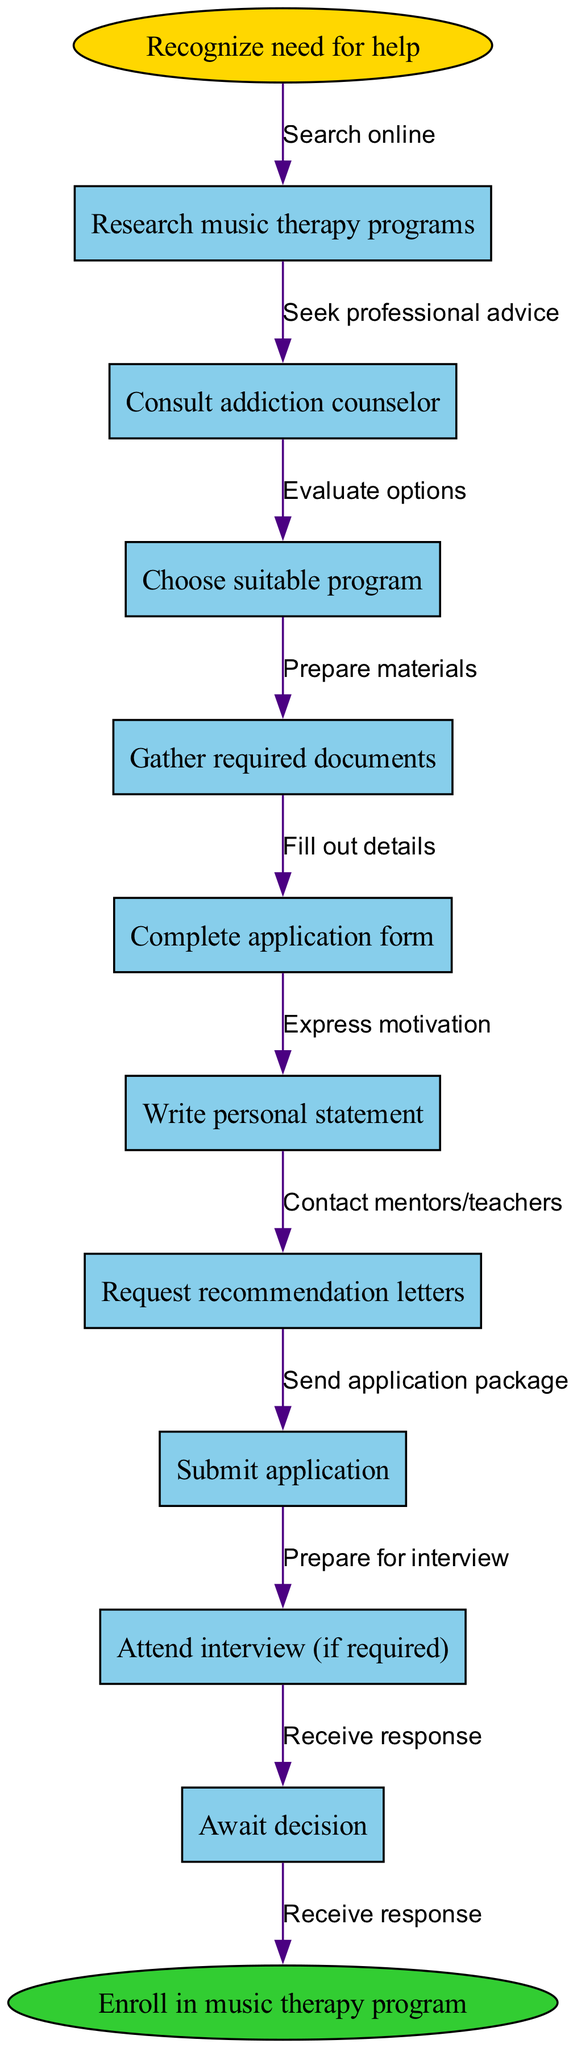What is the first step in the workflow? The first step, indicated at the top of the diagram, is marked with the label "Recognize need for help." This node establishes the starting point of the application process.
Answer: Recognize need for help How many nodes are present in the diagram? By counting all the individual steps included within the "nodes," which are each represented in rectangular shapes, there are a total of eleven nodes (including the start and end).
Answer: Eleven Which node comes after "Consult addiction counselor"? Looking at the flow, after "Consult addiction counselor," the next node directly connected to it is "Choose suitable program." This indicates the sequential nature of the steps in the application process.
Answer: Choose suitable program What is the final step before enrollment in the program? The last action taken in the flow before transitioning to the enrollment phase is represented by the node "Await decision," indicating that applicants must wait for a response following their application submission.
Answer: Await decision What edge connects "Complete application form" to the next node? The edge connecting "Complete application form" to "Write personal statement" is labeled "Fill out details," which signifies the action taken to progress to the next step.
Answer: Fill out details What is the relationship between "Attend interview (if required)" and "Await decision"? "Attend interview (if required)" leads directly to "Await decision," indicating that an interview is a potential step before receiving a decision about the application, contingent on its requirement.
Answer: Leads directly How many edges are used in the diagram? The number of edges corresponds to the connections between nodes, which in this diagram totals ten distinct edges when considering the flow from the start to the end point.
Answer: Ten What is the significance of the "personal statement" node? The "Write personal statement" node signifies an important step where applicants express their motivations and personal journey, which likely plays a crucial role in the application review process.
Answer: Express motivations Which node requires contacting others for support? The node "Request recommendation letters" requires reaching out to mentors or teachers for support, as indicated by the associated edge labeled "Contact mentors/teachers."
Answer: Request recommendation letters 